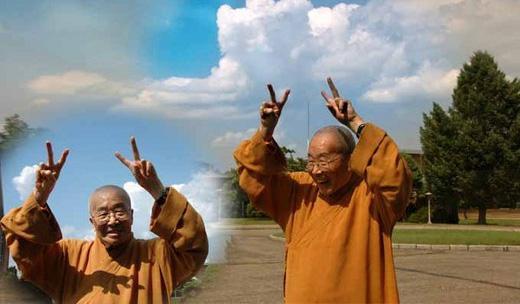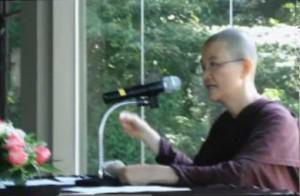The first image is the image on the left, the second image is the image on the right. Analyze the images presented: Is the assertion "At least one image shows a person with a shaved head wearing a solid-colored robe." valid? Answer yes or no. Yes. The first image is the image on the left, the second image is the image on the right. For the images shown, is this caption "At least one person is posing while wearing a robe." true? Answer yes or no. Yes. 